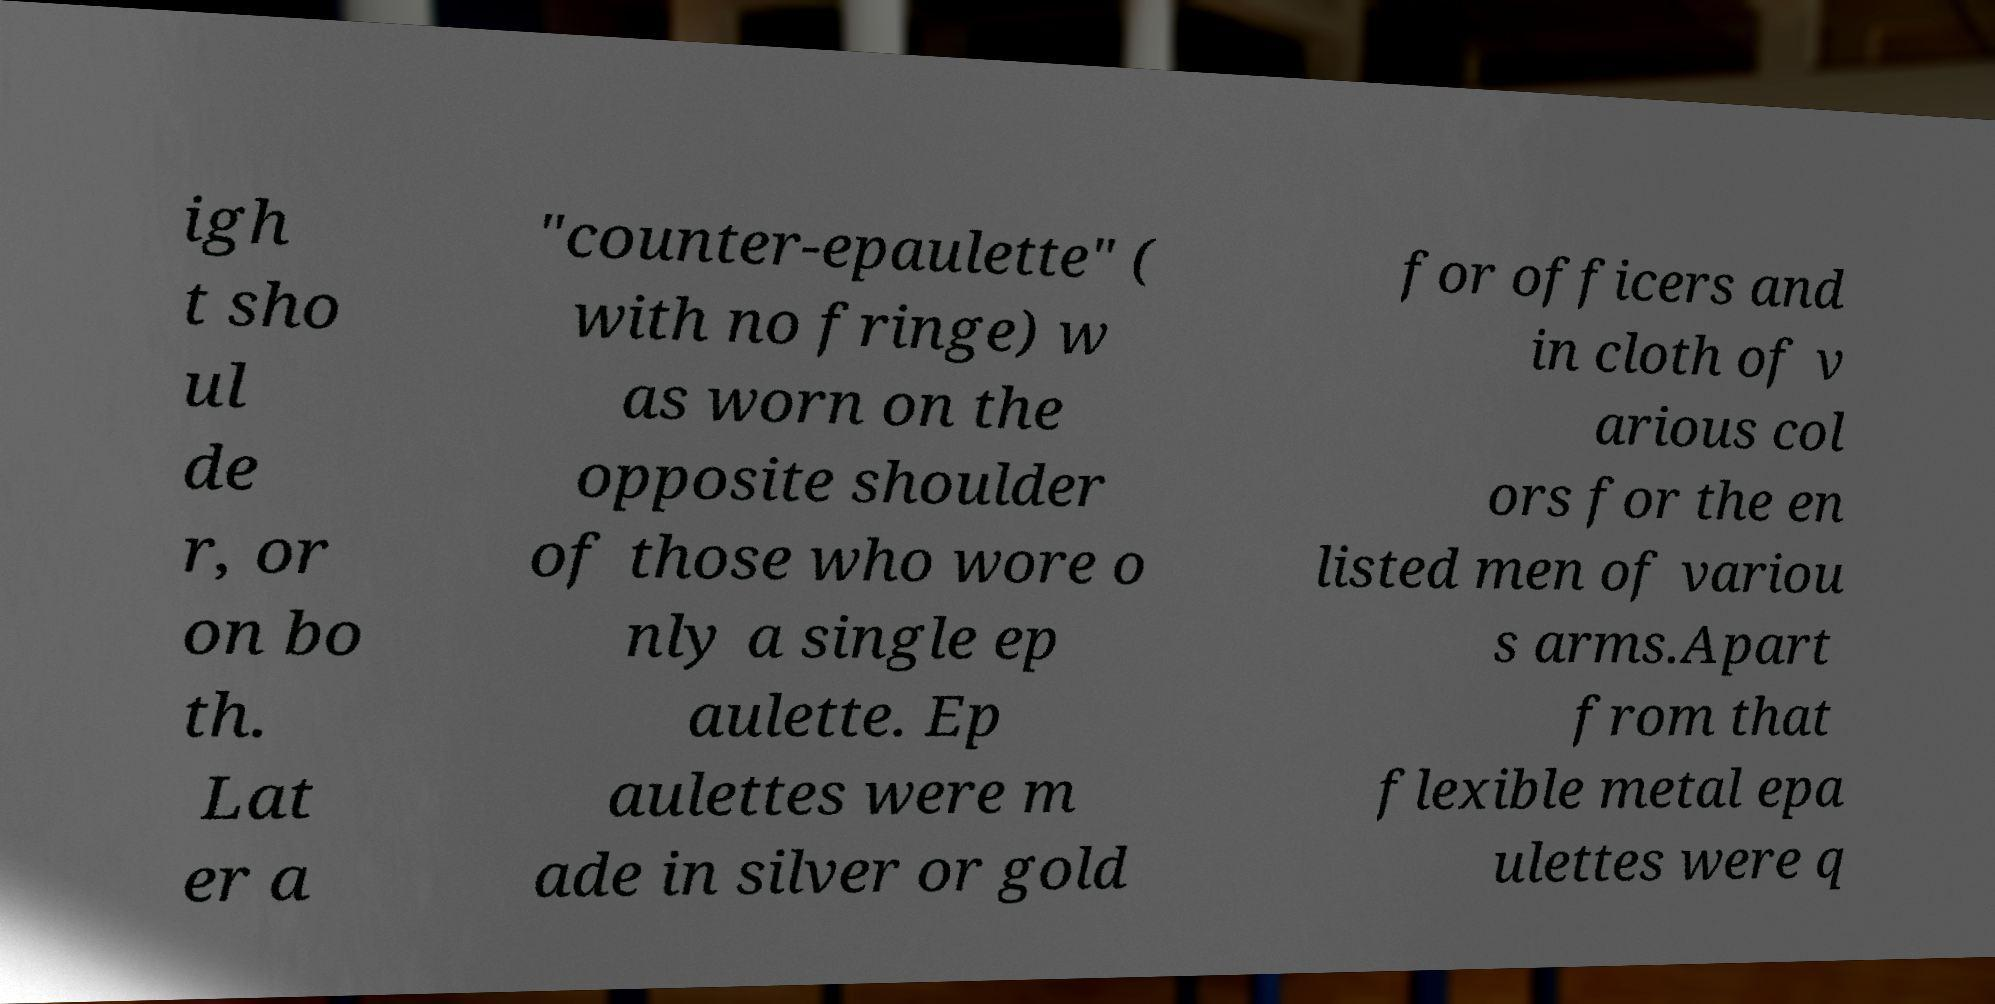Please read and relay the text visible in this image. What does it say? igh t sho ul de r, or on bo th. Lat er a "counter-epaulette" ( with no fringe) w as worn on the opposite shoulder of those who wore o nly a single ep aulette. Ep aulettes were m ade in silver or gold for officers and in cloth of v arious col ors for the en listed men of variou s arms.Apart from that flexible metal epa ulettes were q 